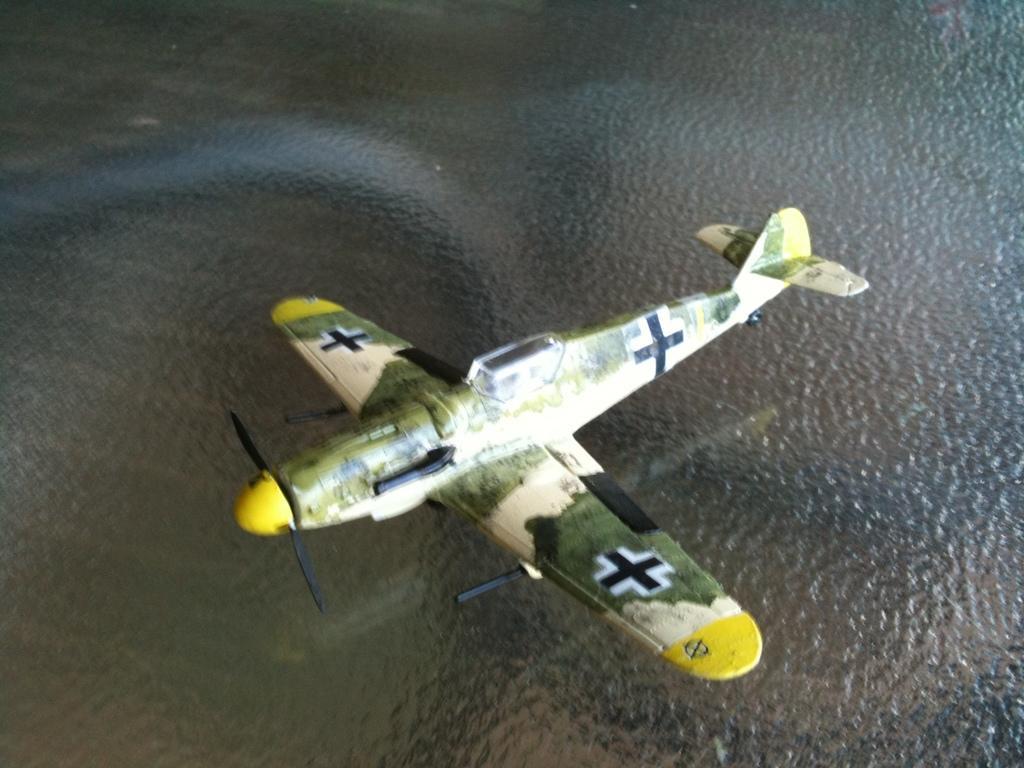Describe this image in one or two sentences. In the center of the picture there is an aircraft, in the air. At the bottom there is a water body. 